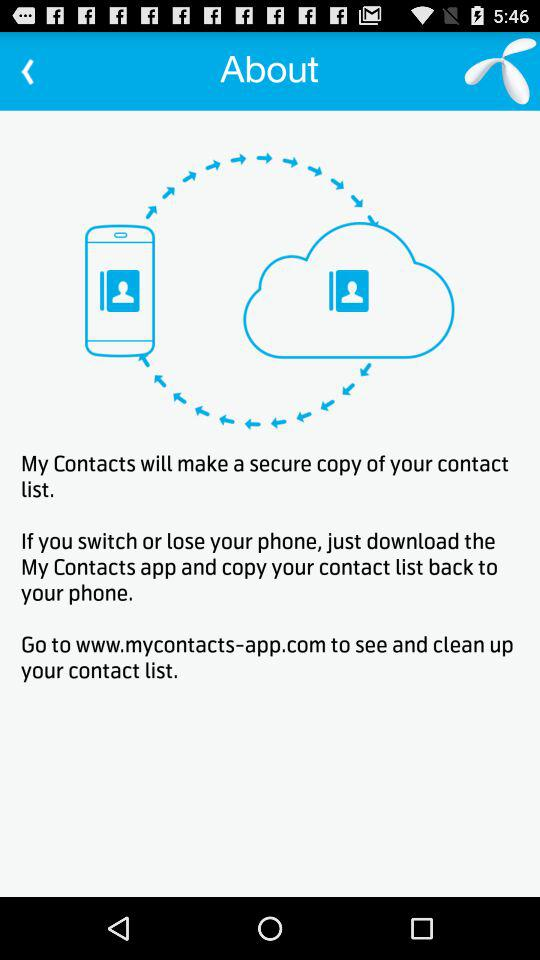What's the website to see and clean up the contact list?
Answer the question using a single word or phrase. The website is www.mycontacts-app.com 